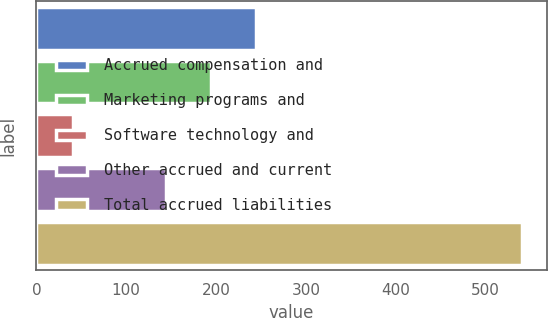Convert chart to OTSL. <chart><loc_0><loc_0><loc_500><loc_500><bar_chart><fcel>Accrued compensation and<fcel>Marketing programs and<fcel>Software technology and<fcel>Other accrued and current<fcel>Total accrued liabilities<nl><fcel>244<fcel>194<fcel>41<fcel>144<fcel>541<nl></chart> 